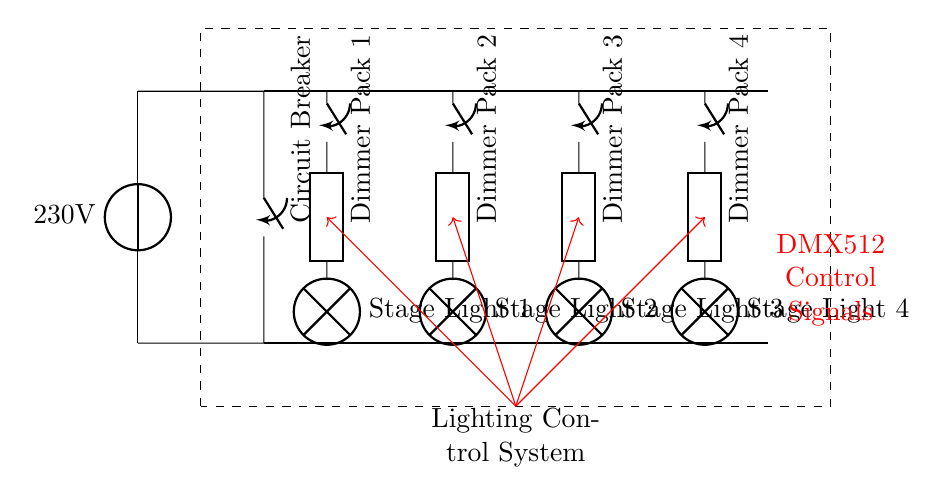What is the main voltage supply for this circuit? The main voltage supply indicated in the circuit is 230V. This is shown at the source symbol labeled with the voltage value.
Answer: 230 volts How many dimmer packs are present in the circuit? The circuit diagram shows four dimmer packs connected to the distribution bus. Each dimmer pack is clearly labeled and positioned vertically along the bus line.
Answer: Four What is the function of DMX512 in this circuit? DMX512 is used to control the dimmer packs through control signals. The red arrows represent the control lines carrying DMX512 signals from the lighting control system to each dimmer pack.
Answer: Control signals What will happen if the circuit breaker is opened? If the circuit breaker is opened, the entire circuit will be disconnected, preventing any current from flowing to the stage lights. The circuit breaker serves as a safety mechanism to isolate the circuit when necessary.
Answer: Disconnect circuit Which components do the stage lights connect to? The stage lights are connected to their respective dimmer packs, with each lamp symbol representing a stage light beneath each dimmer pack. This connection allows for varying light intensity via the dimming controls.
Answer: Dimmer packs What is the purpose of the distribution bus in the circuit? The distribution bus serves to distribute power from the main supply to the individual dimmer packs. It is shown as a thick line in the circuit diagram, indicating its role as the main conduit for electrical distribution.
Answer: Distribute power 